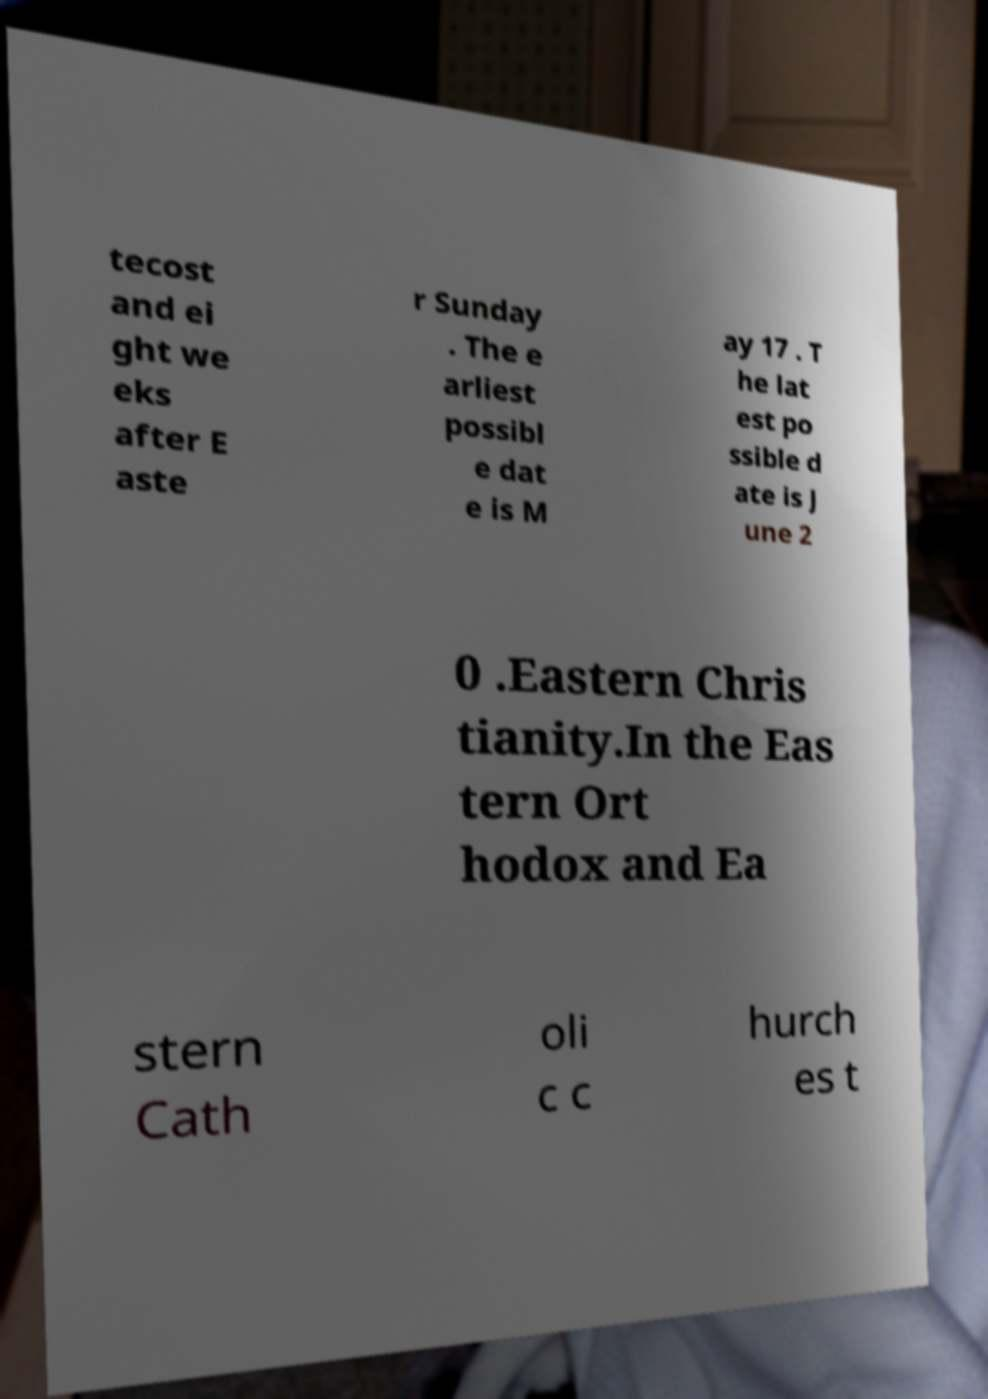Can you accurately transcribe the text from the provided image for me? tecost and ei ght we eks after E aste r Sunday . The e arliest possibl e dat e is M ay 17 . T he lat est po ssible d ate is J une 2 0 .Eastern Chris tianity.In the Eas tern Ort hodox and Ea stern Cath oli c c hurch es t 